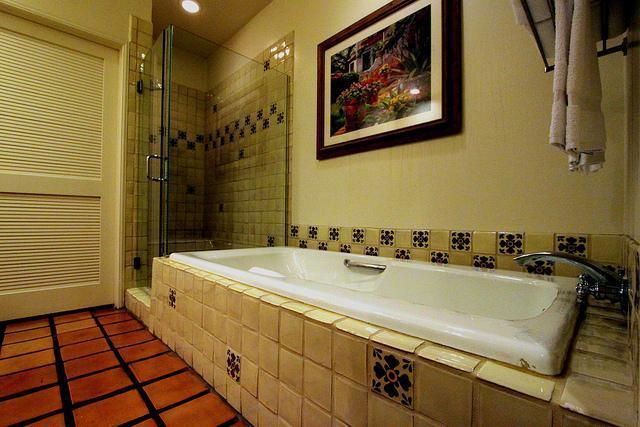How many towels are seen?
Give a very brief answer. 1. 